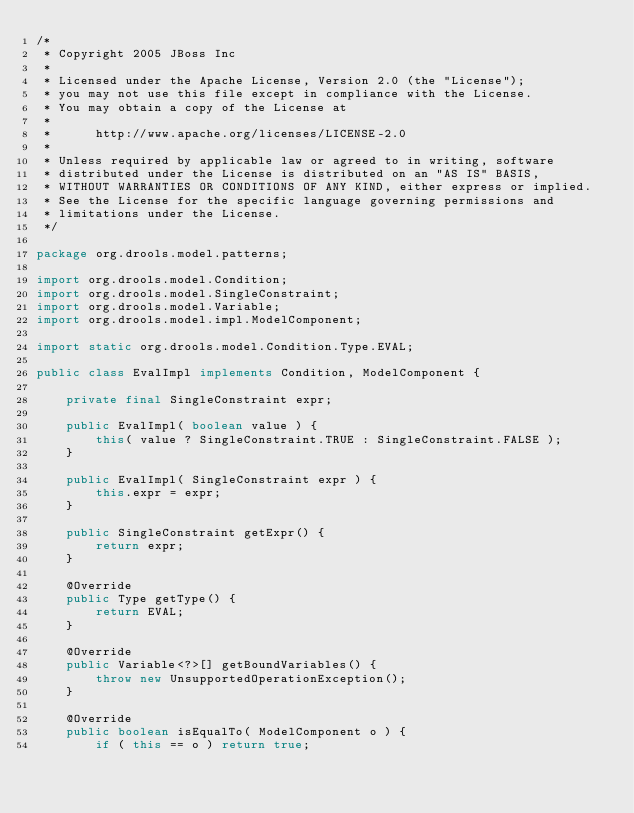<code> <loc_0><loc_0><loc_500><loc_500><_Java_>/*
 * Copyright 2005 JBoss Inc
 *
 * Licensed under the Apache License, Version 2.0 (the "License");
 * you may not use this file except in compliance with the License.
 * You may obtain a copy of the License at
 *
 *      http://www.apache.org/licenses/LICENSE-2.0
 *
 * Unless required by applicable law or agreed to in writing, software
 * distributed under the License is distributed on an "AS IS" BASIS,
 * WITHOUT WARRANTIES OR CONDITIONS OF ANY KIND, either express or implied.
 * See the License for the specific language governing permissions and
 * limitations under the License.
 */

package org.drools.model.patterns;

import org.drools.model.Condition;
import org.drools.model.SingleConstraint;
import org.drools.model.Variable;
import org.drools.model.impl.ModelComponent;

import static org.drools.model.Condition.Type.EVAL;

public class EvalImpl implements Condition, ModelComponent {

    private final SingleConstraint expr;

    public EvalImpl( boolean value ) {
        this( value ? SingleConstraint.TRUE : SingleConstraint.FALSE );
    }

    public EvalImpl( SingleConstraint expr ) {
        this.expr = expr;
    }

    public SingleConstraint getExpr() {
        return expr;
    }

    @Override
    public Type getType() {
        return EVAL;
    }

    @Override
    public Variable<?>[] getBoundVariables() {
        throw new UnsupportedOperationException();
    }

    @Override
    public boolean isEqualTo( ModelComponent o ) {
        if ( this == o ) return true;</code> 